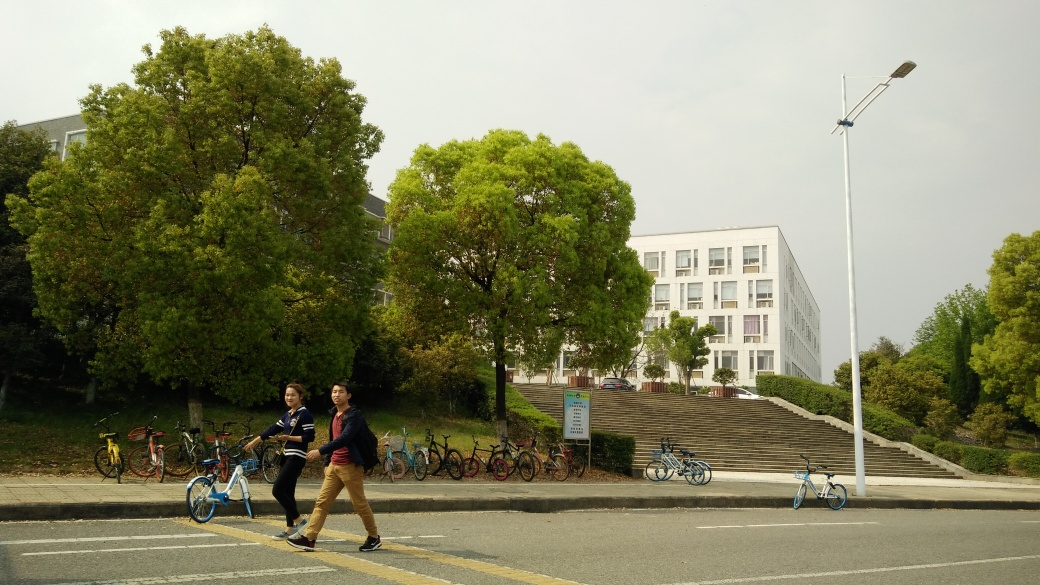How is the weather in the image? The weather in the image appears to be overcast, with a cloudy sky that diffuses the sunlight and provides even lighting across the scene. 